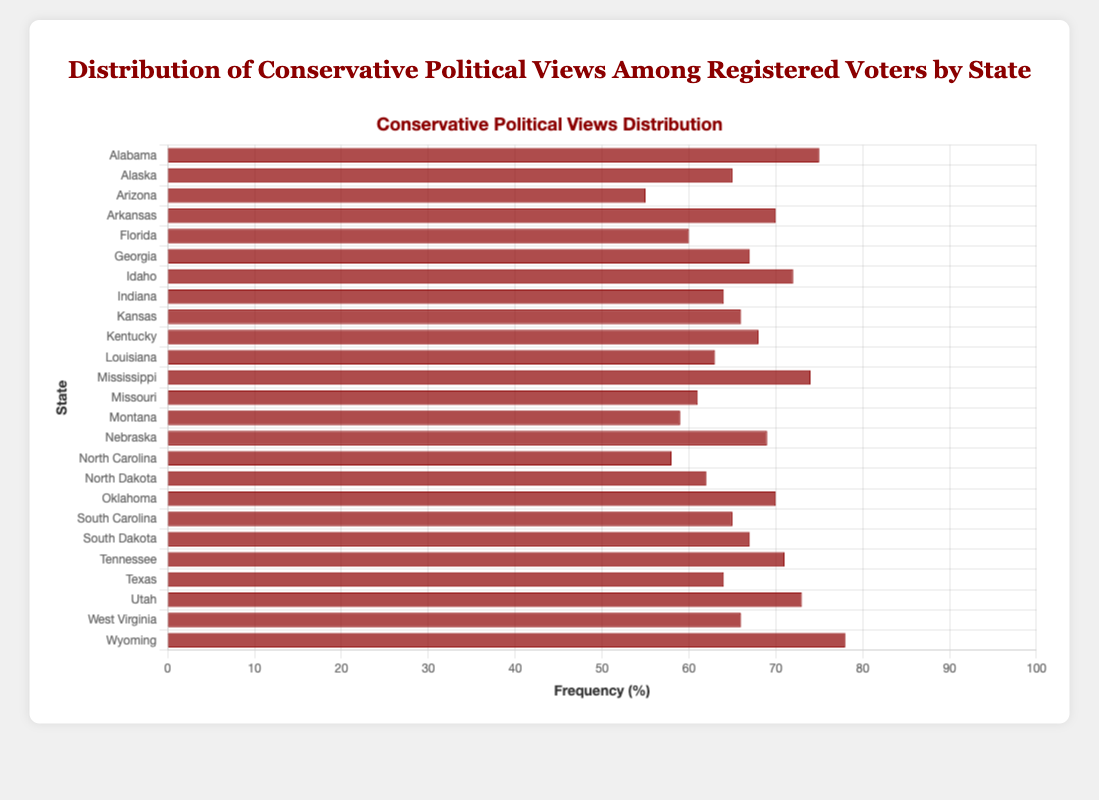Which state has the highest frequency of conservative views among registered voters? To find the highest frequency, look at the bar that extends the farthest to the right. Wyoming has the highest frequency with a value of 78%.
Answer: Wyoming Which state has the lowest frequency of conservative views among registered voters? To find the lowest frequency, look at the bar that extends the least to the right. Arizona has the lowest frequency with a value of 55%.
Answer: Arizona Is the frequency of conservative views in Texas higher or lower than Georgia? Compare the length of the bars for Texas and Georgia. Texas has a frequency of 64%, while Georgia has a frequency of 67%. Thus, Texas is lower.
Answer: Lower What's the median frequency of conservative views among the states listed? List the frequencies in ascending order and find the middle value. The ordered frequencies are: 55, 58, 59, 60, 61, 62, 63, 64, 64, 65, 65, 66, 66, 67, 67, 68, 69, 70, 70, 71, 72, 73, 74, 75, 78. The median is the 13th value, which is 66%.
Answer: 66% How many states have a frequency of conservative views below 60%? Count the number of bars with lengths translating to frequencies below 60%. The states are Arizona (55%), North Carolina (58%), and Montana (59%).
Answer: 3 What is the average frequency of conservative views for all states listed? Add up all the frequencies and divide by the number of states. Sum: 75 + 65 + 55 + 70 + 60 + 67 + 72 + 64 + 66 + 68 + 63 + 74 + 61 + 59 + 69 + 58 + 62 + 70 + 65 + 67 + 71 + 64 + 73 + 66 + 78 = 1597. Average: 1597 / 25 ≈ 63.88%.
Answer: 63.88% Which states have a frequency within 5% of the highest frequency? The highest frequency is 78%, so within 5% would be frequencies between 73% and 78%. The states are Utah (73%) and Alabama (75%).
Answer: Utah, Alabama Does Mississippi have a higher frequency of conservative views than South Carolina? Compare the bars for Mississippi and South Carolina. Mississippi has a frequency of 74%, while South Carolina has a frequency of 65%. Thus, Mississippi is higher.
Answer: Higher What is the range of frequencies for conservative views among the states? The range is the difference between the highest and lowest frequencies. Highest: 78% (Wyoming), Lowest: 55% (Arizona). Range: 78% - 55% = 23%.
Answer: 23% 